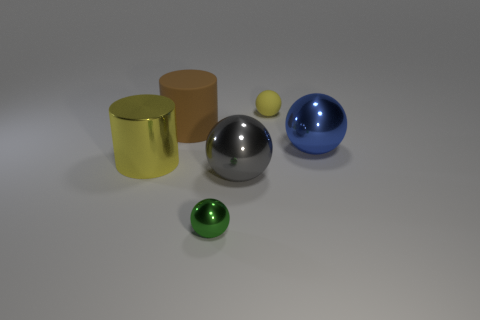Subtract all brown balls. Subtract all cyan cubes. How many balls are left? 4 Add 3 metallic things. How many objects exist? 9 Subtract all cylinders. How many objects are left? 4 Add 2 small green cylinders. How many small green cylinders exist? 2 Subtract 0 brown blocks. How many objects are left? 6 Subtract all small rubber objects. Subtract all blue balls. How many objects are left? 4 Add 2 tiny yellow things. How many tiny yellow things are left? 3 